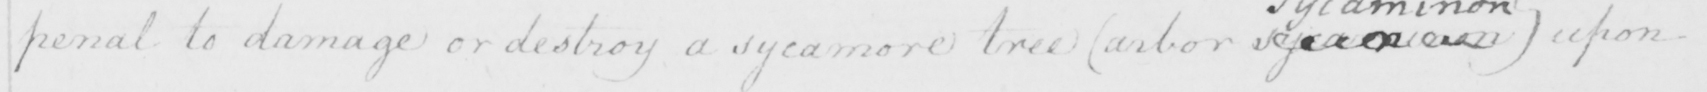Can you tell me what this handwritten text says? penal to damage or destroy a sycamore tree  ( arbor  <gap/>   )  upon 